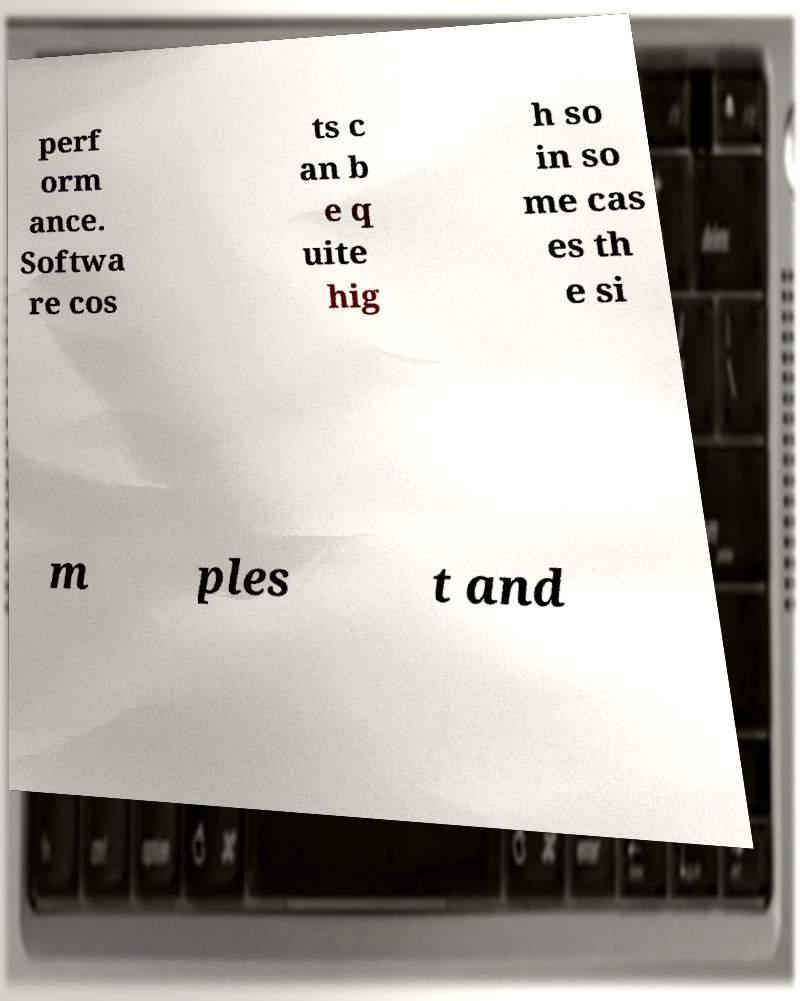Please read and relay the text visible in this image. What does it say? perf orm ance. Softwa re cos ts c an b e q uite hig h so in so me cas es th e si m ples t and 